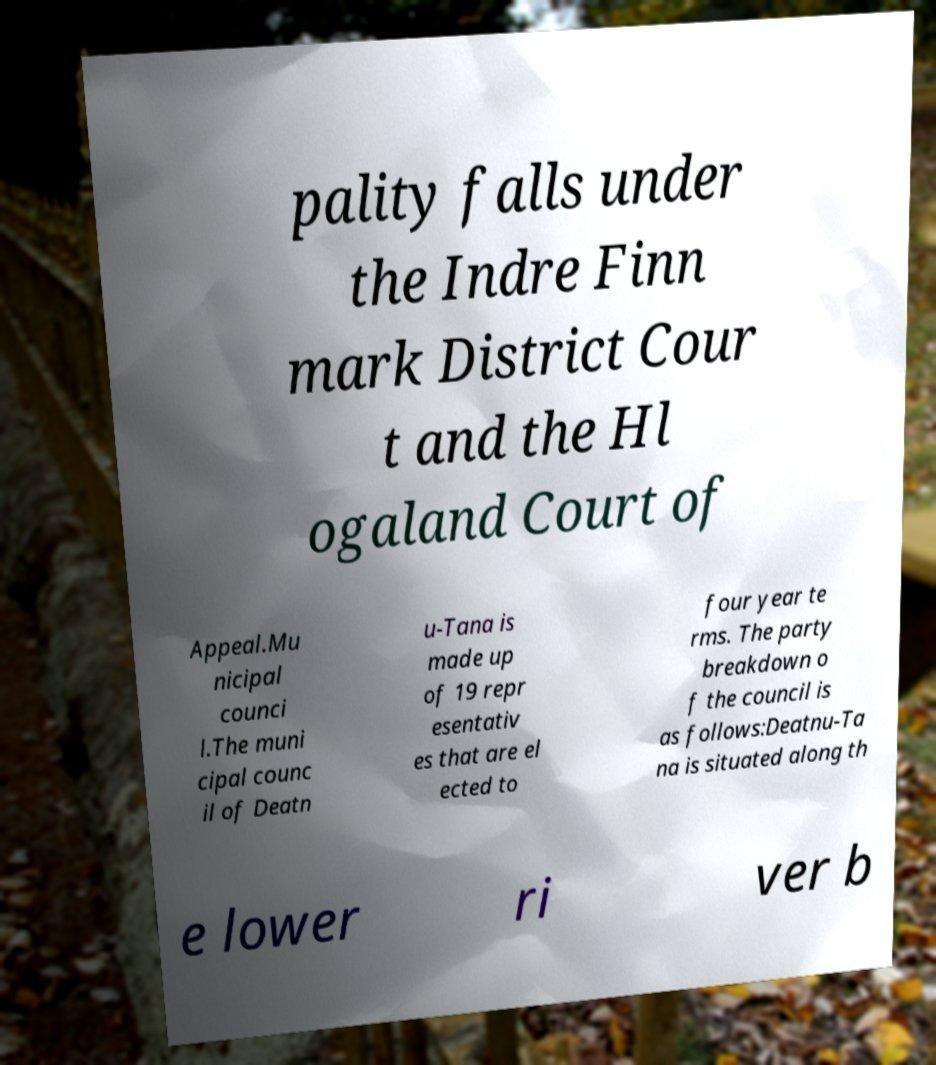Can you read and provide the text displayed in the image?This photo seems to have some interesting text. Can you extract and type it out for me? pality falls under the Indre Finn mark District Cour t and the Hl ogaland Court of Appeal.Mu nicipal counci l.The muni cipal counc il of Deatn u-Tana is made up of 19 repr esentativ es that are el ected to four year te rms. The party breakdown o f the council is as follows:Deatnu-Ta na is situated along th e lower ri ver b 